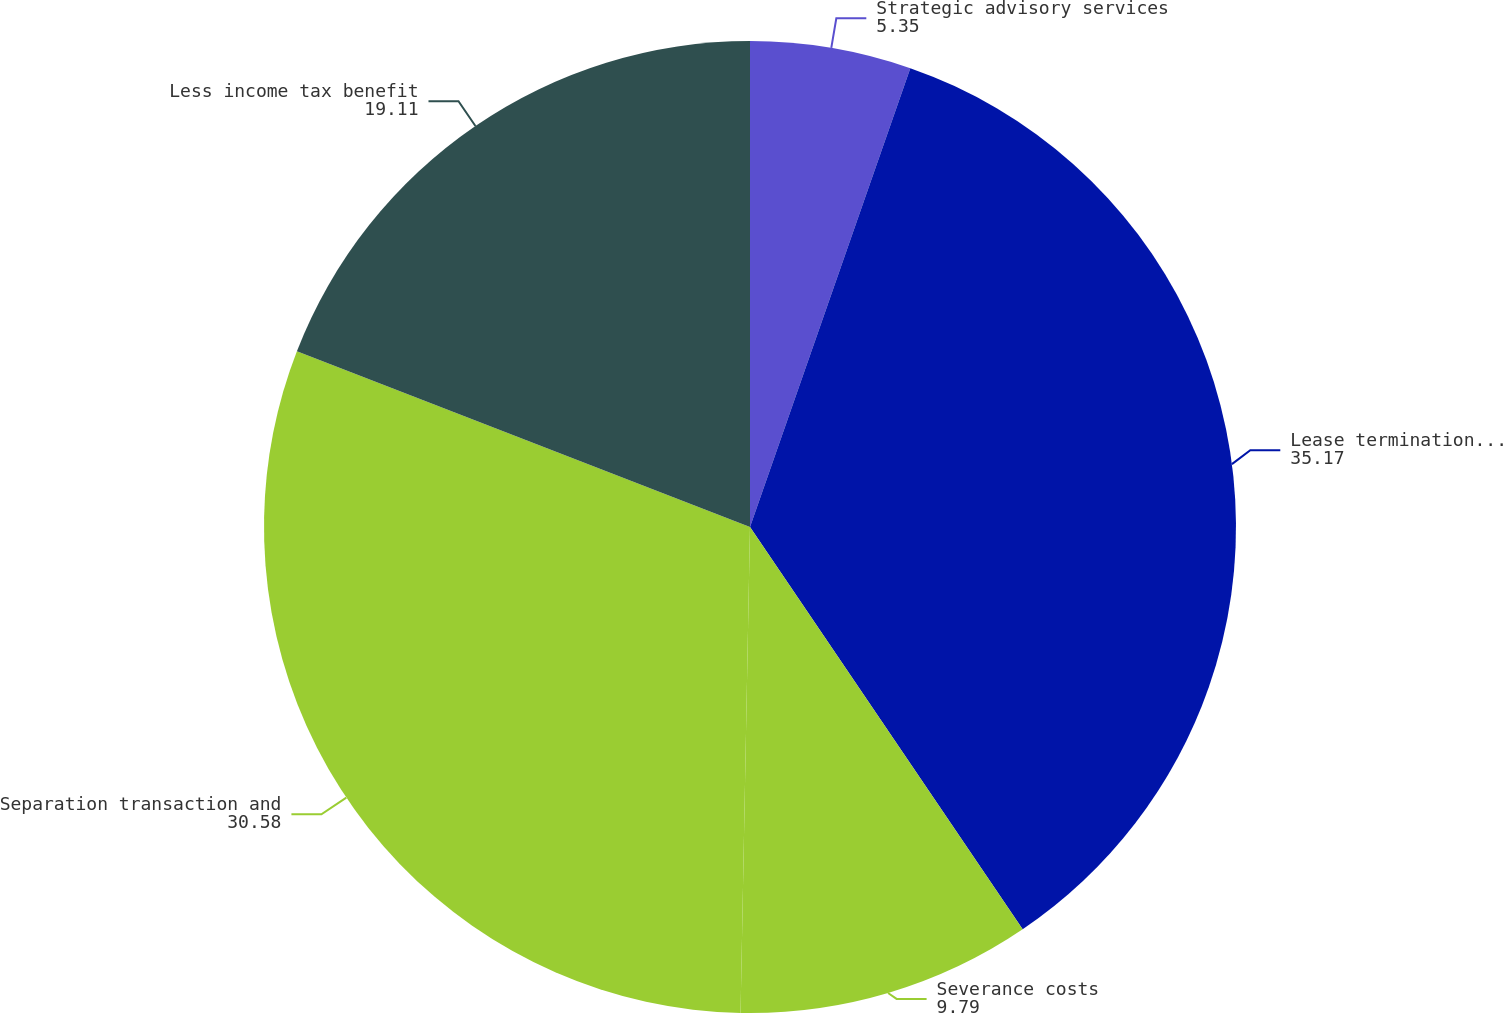Convert chart to OTSL. <chart><loc_0><loc_0><loc_500><loc_500><pie_chart><fcel>Strategic advisory services<fcel>Lease termination and facility<fcel>Severance costs<fcel>Separation transaction and<fcel>Less income tax benefit<nl><fcel>5.35%<fcel>35.17%<fcel>9.79%<fcel>30.58%<fcel>19.11%<nl></chart> 